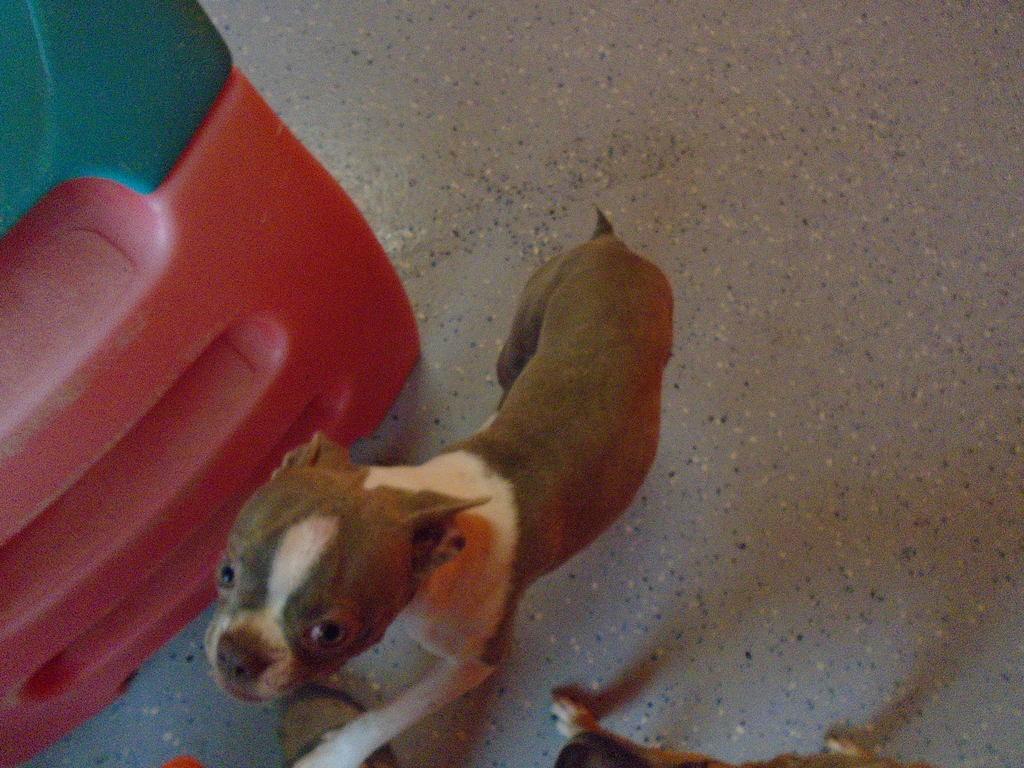Can you describe this image briefly? There is a dog on the floor. On the left side of the image we can see an object which is in red and green color. 